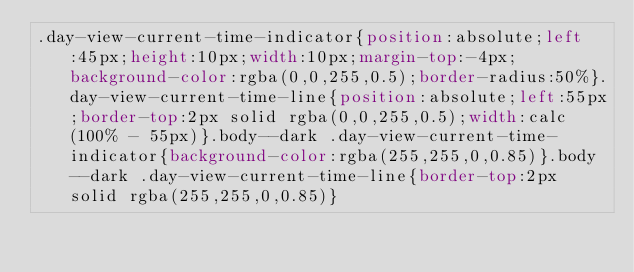<code> <loc_0><loc_0><loc_500><loc_500><_CSS_>.day-view-current-time-indicator{position:absolute;left:45px;height:10px;width:10px;margin-top:-4px;background-color:rgba(0,0,255,0.5);border-radius:50%}.day-view-current-time-line{position:absolute;left:55px;border-top:2px solid rgba(0,0,255,0.5);width:calc(100% - 55px)}.body--dark .day-view-current-time-indicator{background-color:rgba(255,255,0,0.85)}.body--dark .day-view-current-time-line{border-top:2px solid rgba(255,255,0,0.85)}</code> 